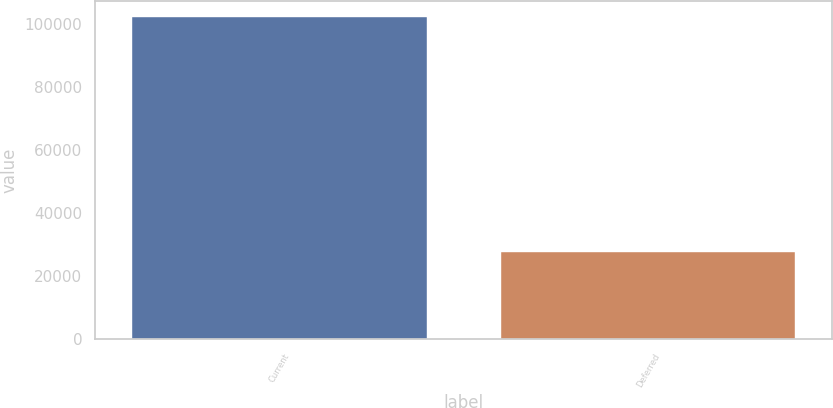Convert chart to OTSL. <chart><loc_0><loc_0><loc_500><loc_500><bar_chart><fcel>Current<fcel>Deferred<nl><fcel>102212<fcel>27681<nl></chart> 